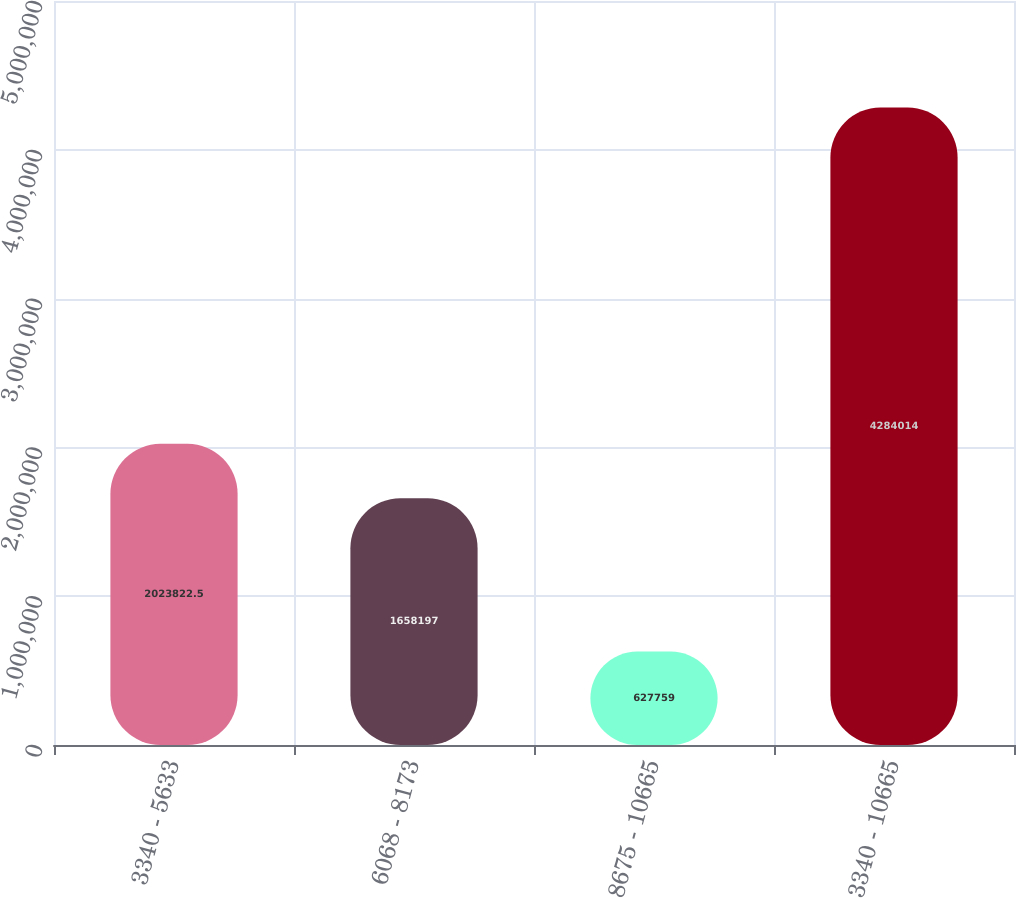<chart> <loc_0><loc_0><loc_500><loc_500><bar_chart><fcel>3340 - 5633<fcel>6068 - 8173<fcel>8675 - 10665<fcel>3340 - 10665<nl><fcel>2.02382e+06<fcel>1.6582e+06<fcel>627759<fcel>4.28401e+06<nl></chart> 